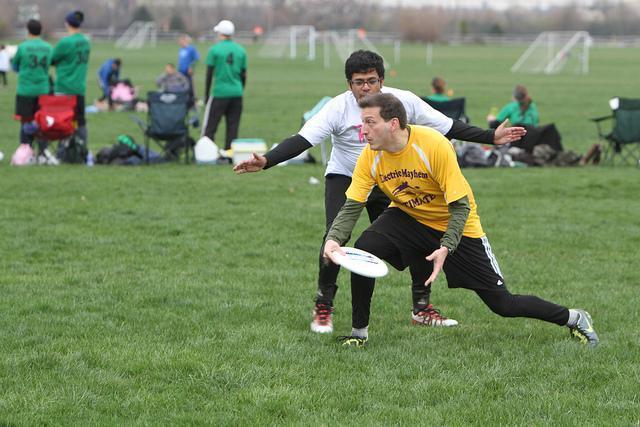How many people are there?
Give a very brief answer. 5. How many hands does the gold-rimmed clock have?
Give a very brief answer. 0. 